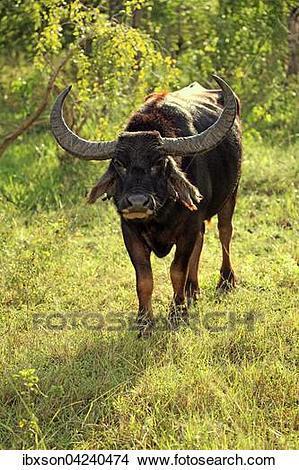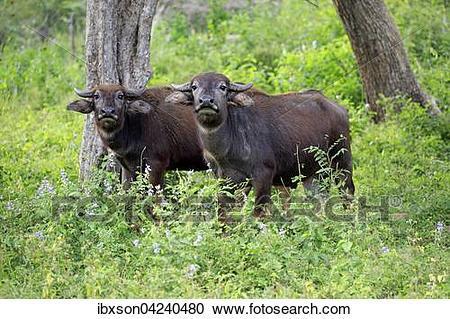The first image is the image on the left, the second image is the image on the right. Examine the images to the left and right. Is the description "There are exactly three animals with horns that are visible." accurate? Answer yes or no. Yes. The first image is the image on the left, the second image is the image on the right. Assess this claim about the two images: "There are exactly three animals in total.". Correct or not? Answer yes or no. Yes. 